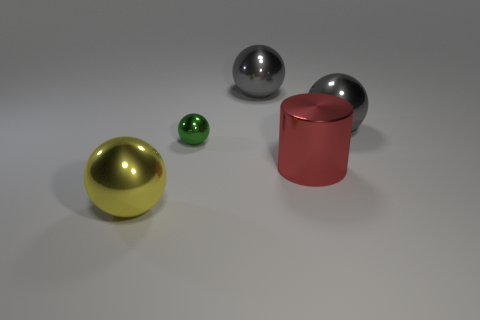What might be the purpose of this arrangement of objects? This arrangement could serve as a study of shapes, colors, and materials in a controlled lighting environment, often used in 3D rendering tests or artistic compositions to demonstrate texture and reflectivity properties. 